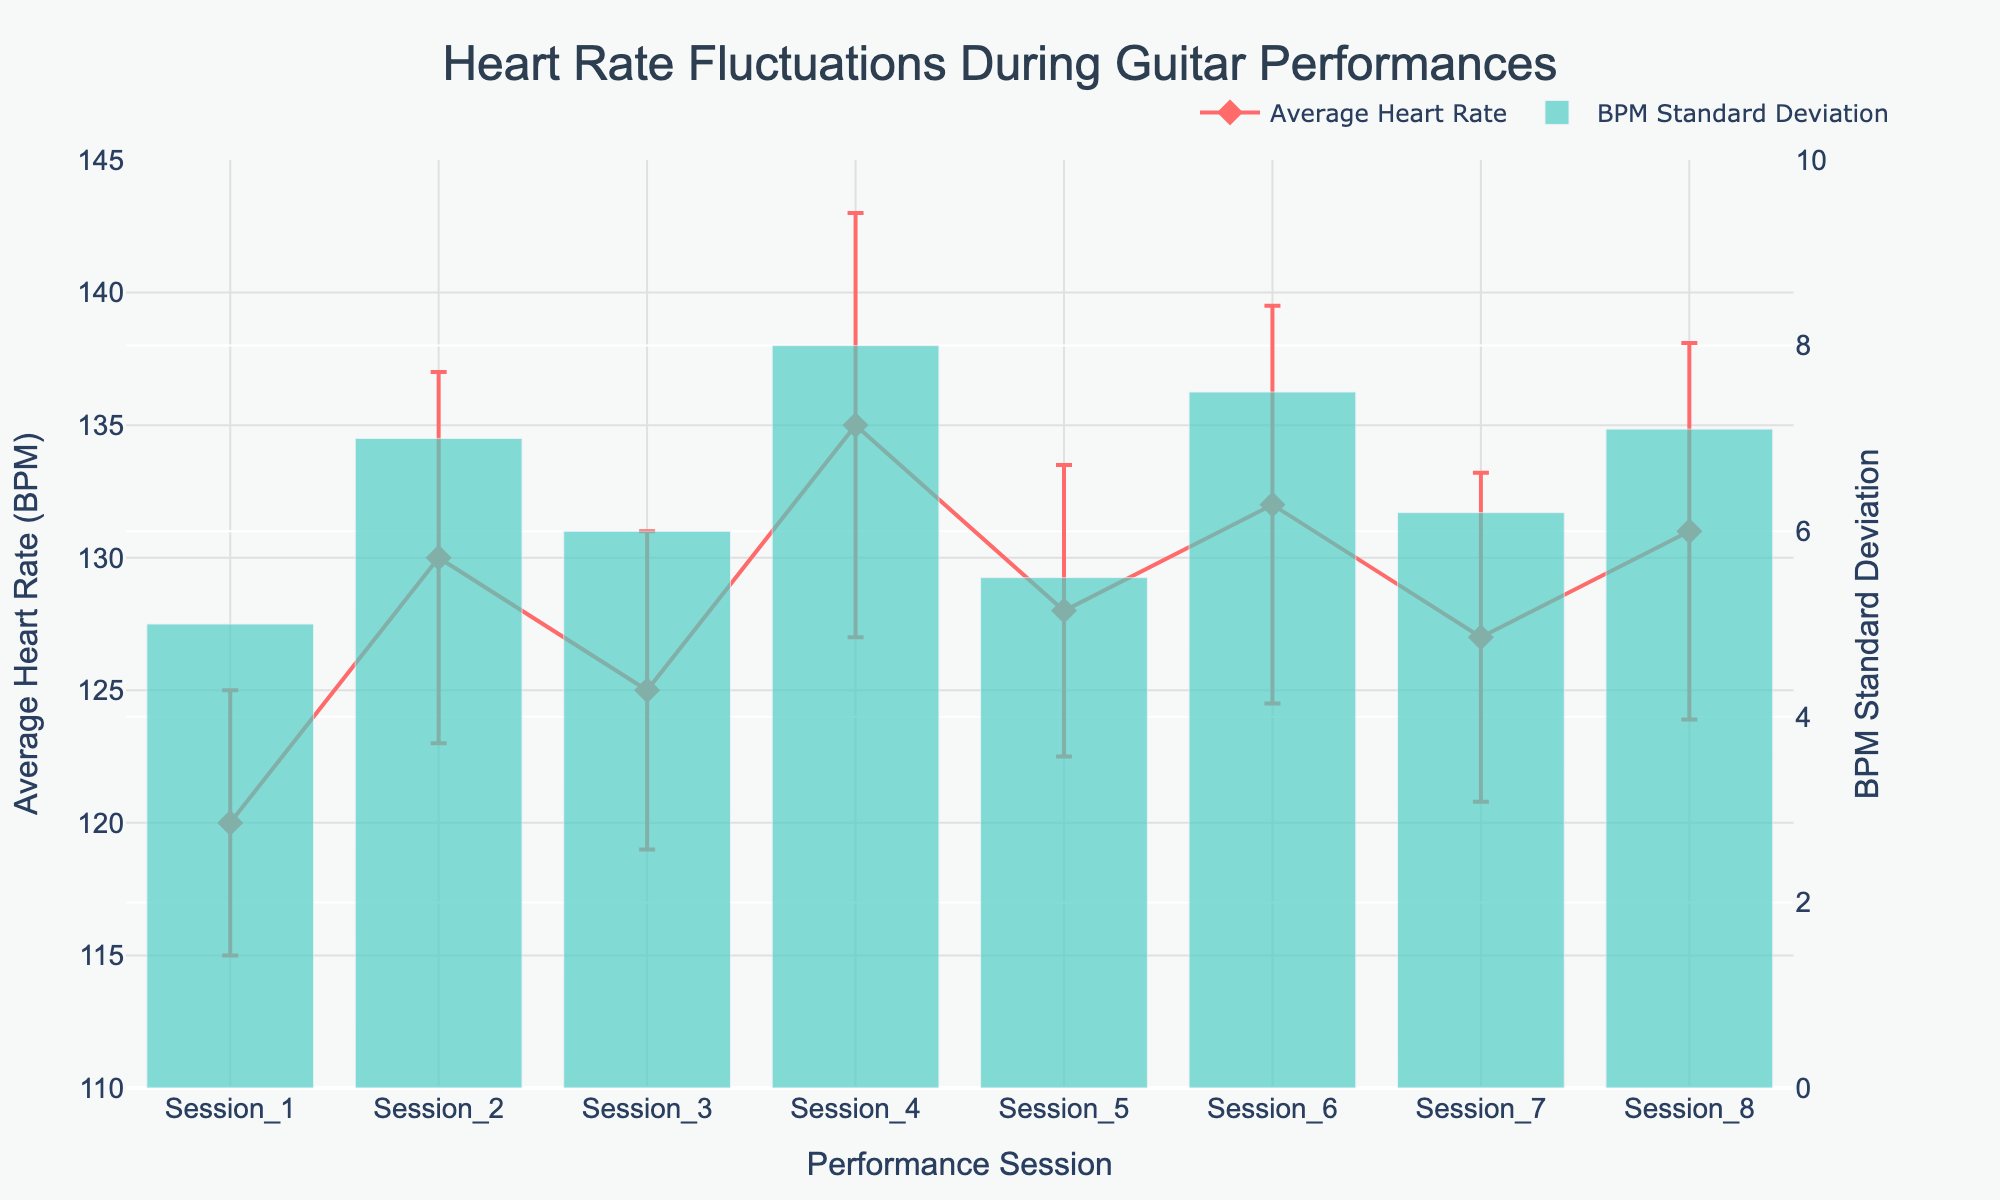what is the average heart rate in Session 3? The figure shows the average heart rate for each performance session. For Session 3, the average heart rate is marked directly on the plot.
Answer: 125 What is the highest average heart rate recorded during the performances? By looking at the plot, the highest average heart rate is indicated by the peak on the y-axis for the performance sessions. For this plot, the highest average heart rate is recorded at Session 4.
Answer: 135 Which session has the widest confidence interval for average heart rate? Compare the lengths of the error bars representing the confidence intervals for each session. The widest interval is determined by the largest difference between the upper and lower bounds. Session 4 has the longest error bars.
Answer: Session 4 What is the range of BPM Standard Deviation for Session 2? The BPM standard deviation values are shown as bars for each session. For Session 2, the BPM standard deviation is 7.
Answer: 7 How does the average heart rate trend from Session 1 to Session 8? To see the trend, observe the line connecting the average heart rate points from Session 1 to Session 8. The trend can be identified by checking if the line is mostly increasing, decreasing, or fluctuating. The plot shows some fluctuations but an overall increasing trend.
Answer: Overall increasing Compare the standard deviations in heart rate for Session 5 and Session 6. Locate the bars representing BPM standard deviation for Sessions 5 and 6. For Session 5, the standard deviation is 5.5, and for Session 6, it is 7.5.
Answer: Session 6 has a higher standard deviation What is the difference between the average heart rate in Session 4 and Session 5? Find the average heart rates for Sessions 4 and 5 on the y-axis. Session 4 has an average heart rate of 135, and Session 5 has 128. Subtracting these values gives the difference.
Answer: 7 Which session has the smallest BPM standard deviation? Look for the shortest bar representing BPM standard deviation across all sessions. The smallest bar is for Session 1 with a standard deviation of 5.
Answer: Session 1 How does the confidence interval for Session 8 compare to that of Session 2? Evaluate the lengths of error bars for Sessions 8 and 2. Session 8 has a smaller confidence interval, and it is represented with shorter error bars compared to Session 2.
Answer: Session 8's confidence interval is smaller 